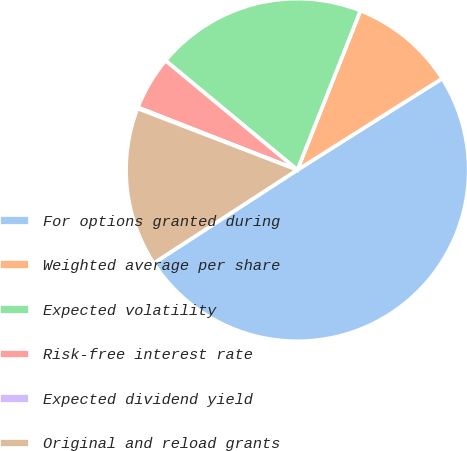Convert chart to OTSL. <chart><loc_0><loc_0><loc_500><loc_500><pie_chart><fcel>For options granted during<fcel>Weighted average per share<fcel>Expected volatility<fcel>Risk-free interest rate<fcel>Expected dividend yield<fcel>Original and reload grants<nl><fcel>49.8%<fcel>10.04%<fcel>19.98%<fcel>5.07%<fcel>0.1%<fcel>15.01%<nl></chart> 